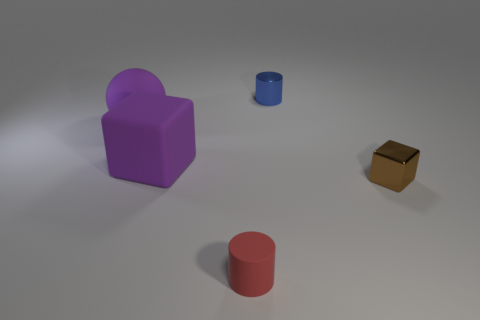There is a object that is the same size as the purple rubber cube; what is its shape? sphere 